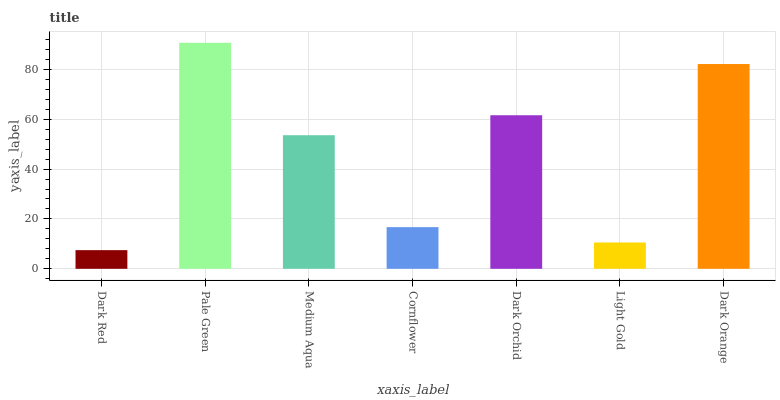Is Dark Red the minimum?
Answer yes or no. Yes. Is Pale Green the maximum?
Answer yes or no. Yes. Is Medium Aqua the minimum?
Answer yes or no. No. Is Medium Aqua the maximum?
Answer yes or no. No. Is Pale Green greater than Medium Aqua?
Answer yes or no. Yes. Is Medium Aqua less than Pale Green?
Answer yes or no. Yes. Is Medium Aqua greater than Pale Green?
Answer yes or no. No. Is Pale Green less than Medium Aqua?
Answer yes or no. No. Is Medium Aqua the high median?
Answer yes or no. Yes. Is Medium Aqua the low median?
Answer yes or no. Yes. Is Dark Red the high median?
Answer yes or no. No. Is Pale Green the low median?
Answer yes or no. No. 